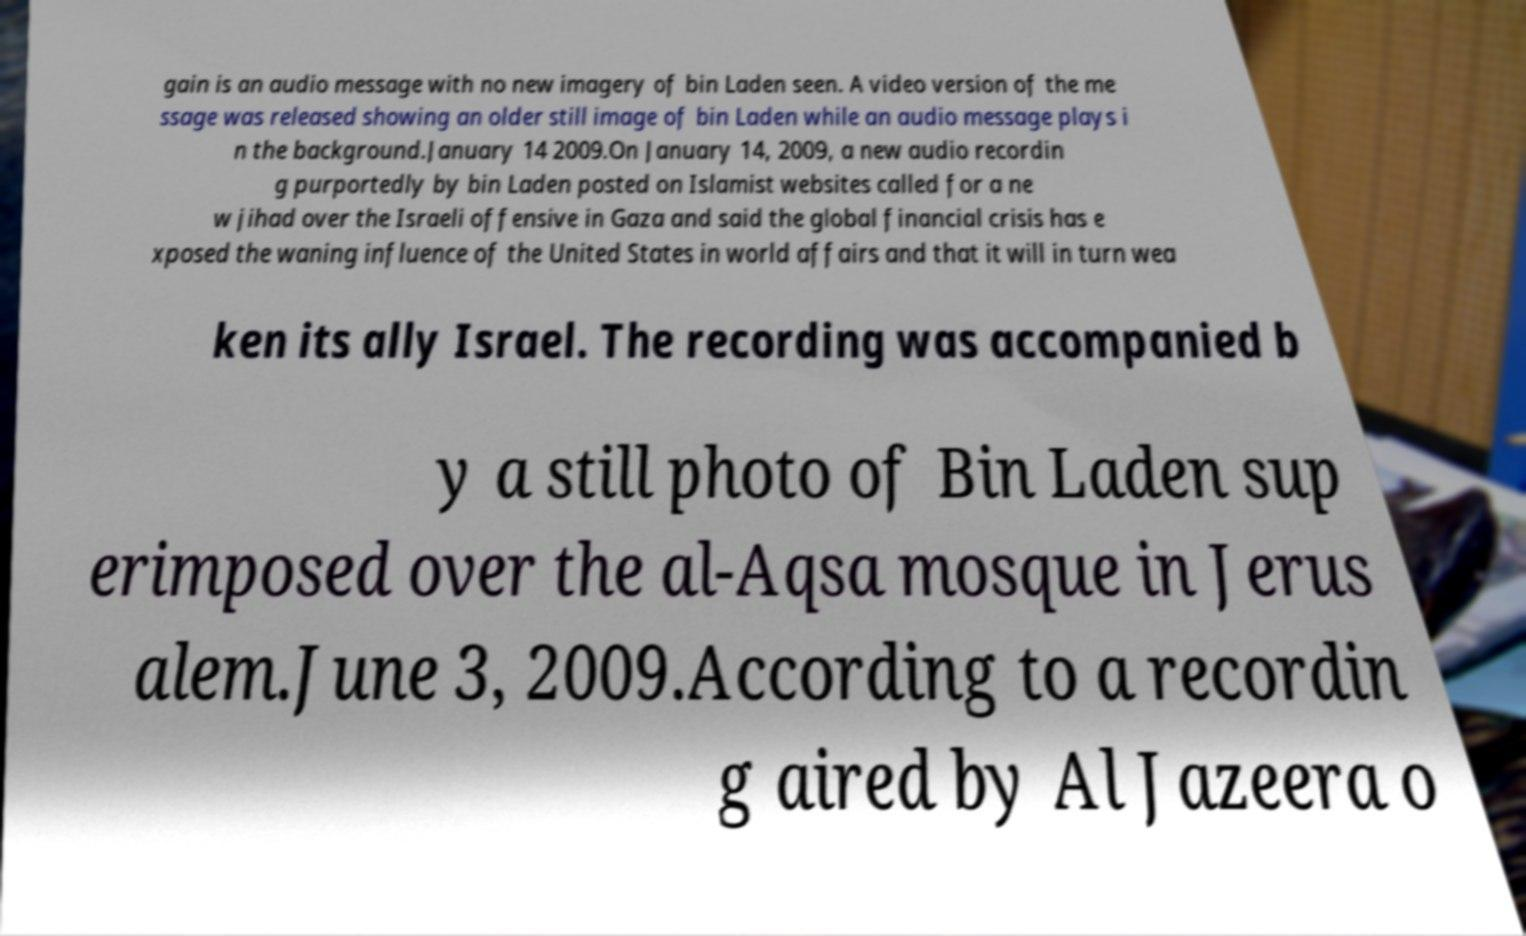There's text embedded in this image that I need extracted. Can you transcribe it verbatim? gain is an audio message with no new imagery of bin Laden seen. A video version of the me ssage was released showing an older still image of bin Laden while an audio message plays i n the background.January 14 2009.On January 14, 2009, a new audio recordin g purportedly by bin Laden posted on Islamist websites called for a ne w jihad over the Israeli offensive in Gaza and said the global financial crisis has e xposed the waning influence of the United States in world affairs and that it will in turn wea ken its ally Israel. The recording was accompanied b y a still photo of Bin Laden sup erimposed over the al-Aqsa mosque in Jerus alem.June 3, 2009.According to a recordin g aired by Al Jazeera o 